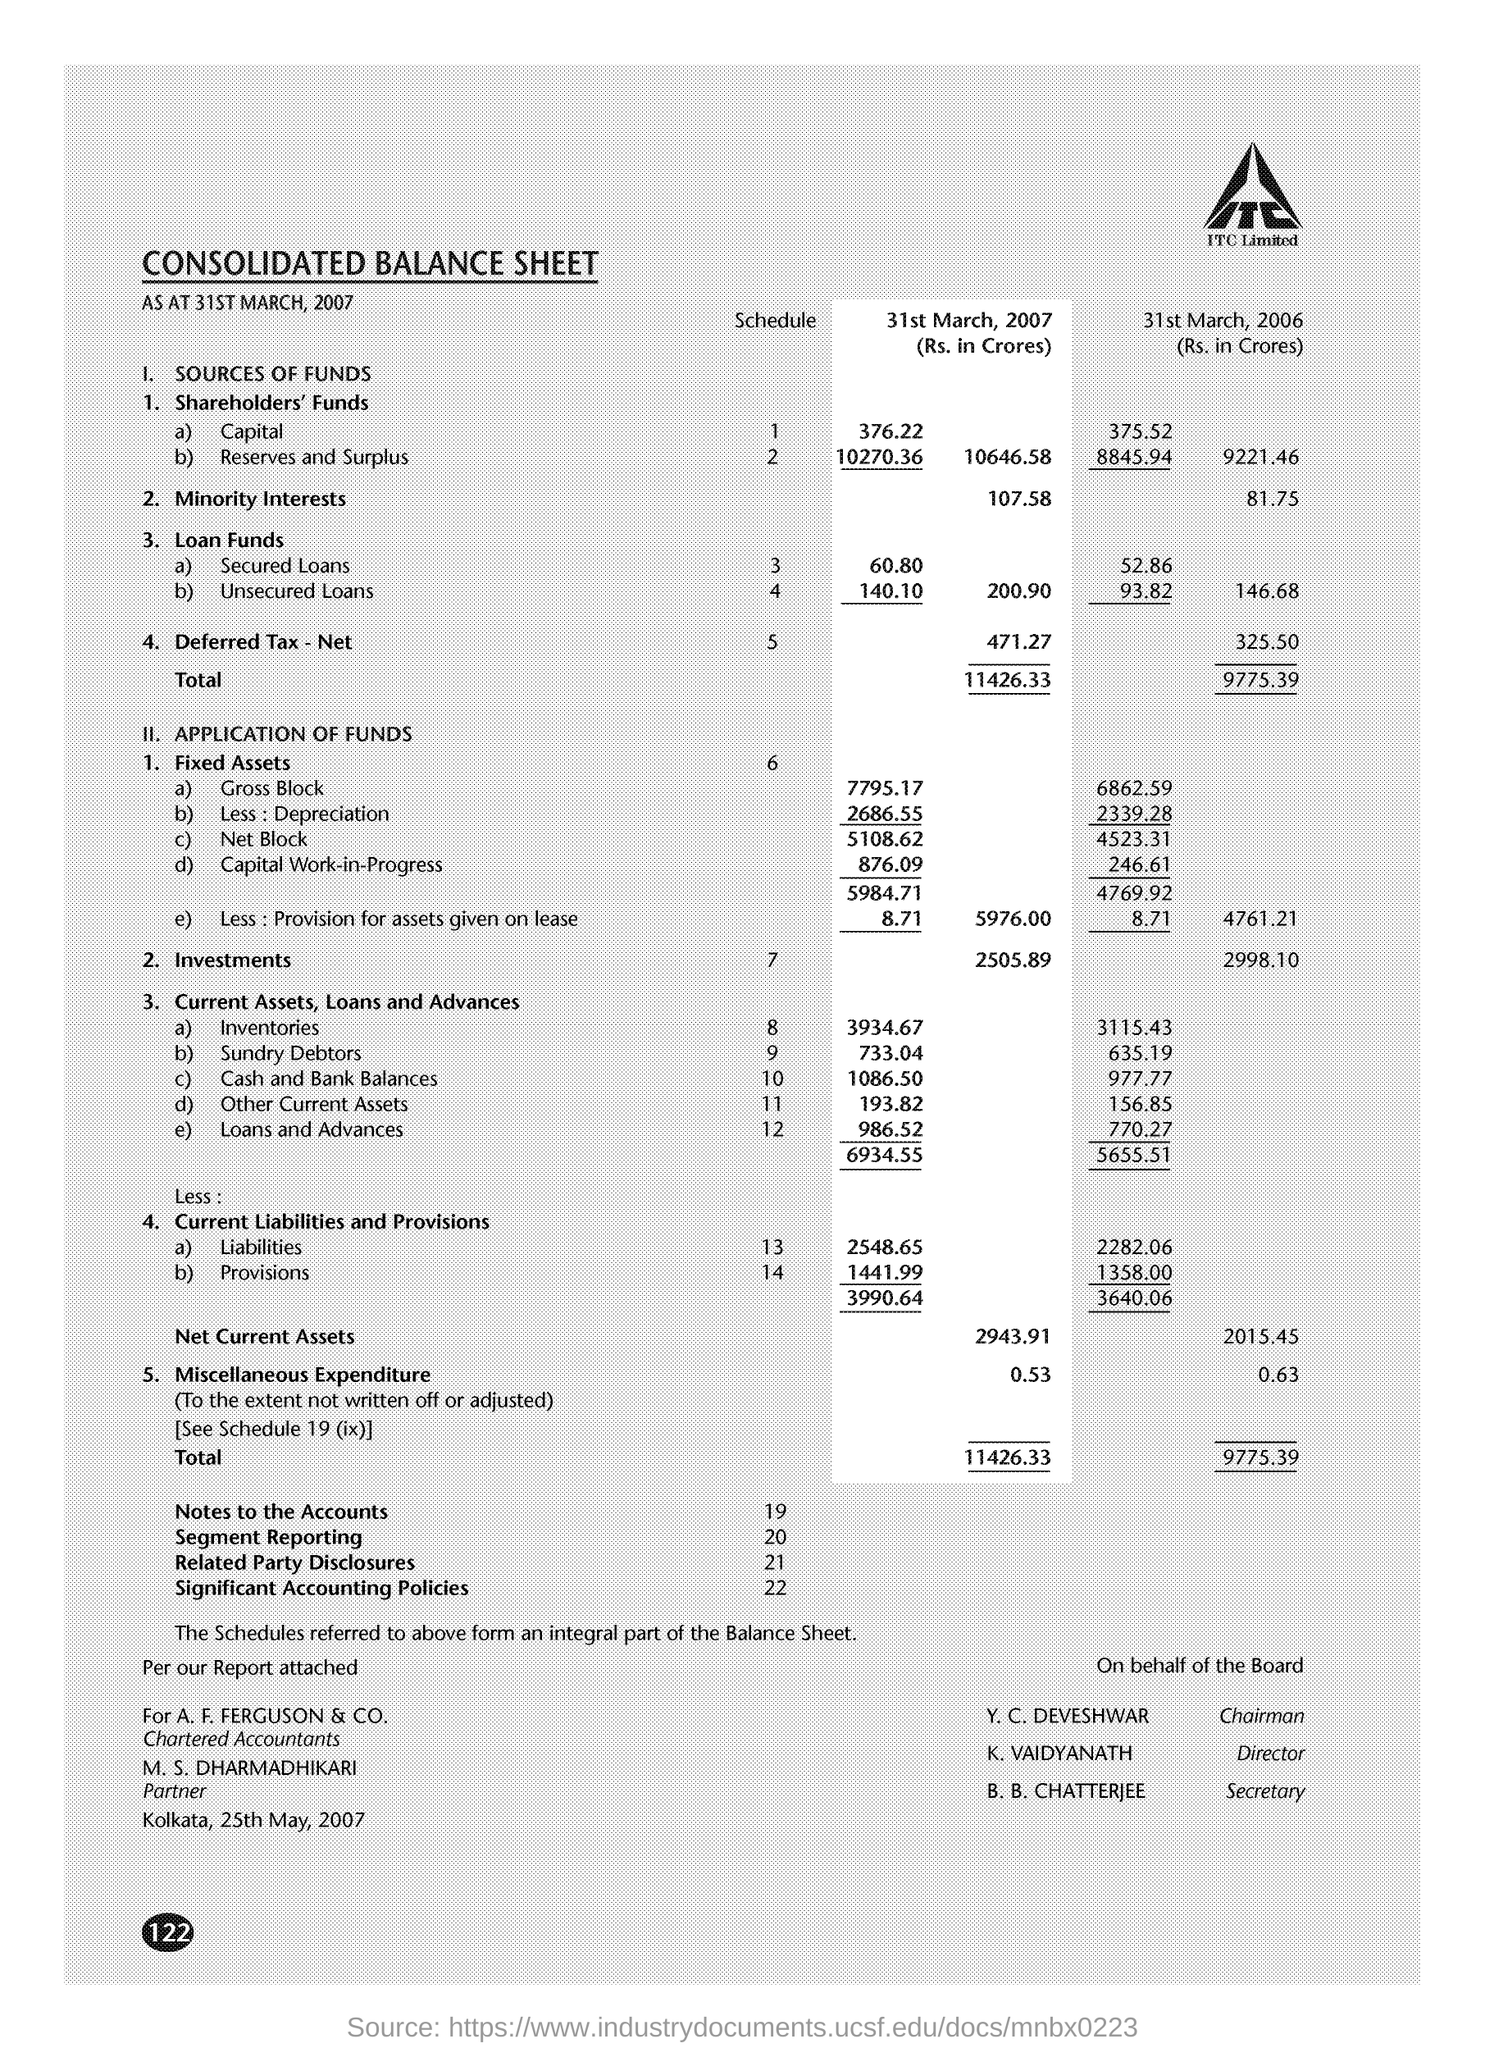What are the Net Current Assets for 31st March 2006? The Net Current Assets for ITC Limited on 31st March 2006 were ₹2015.45 Crores, as detailed in the 'Current Assets, Loans and Advances' section, after deducting the 'Current Liabilities and Provisions'. 